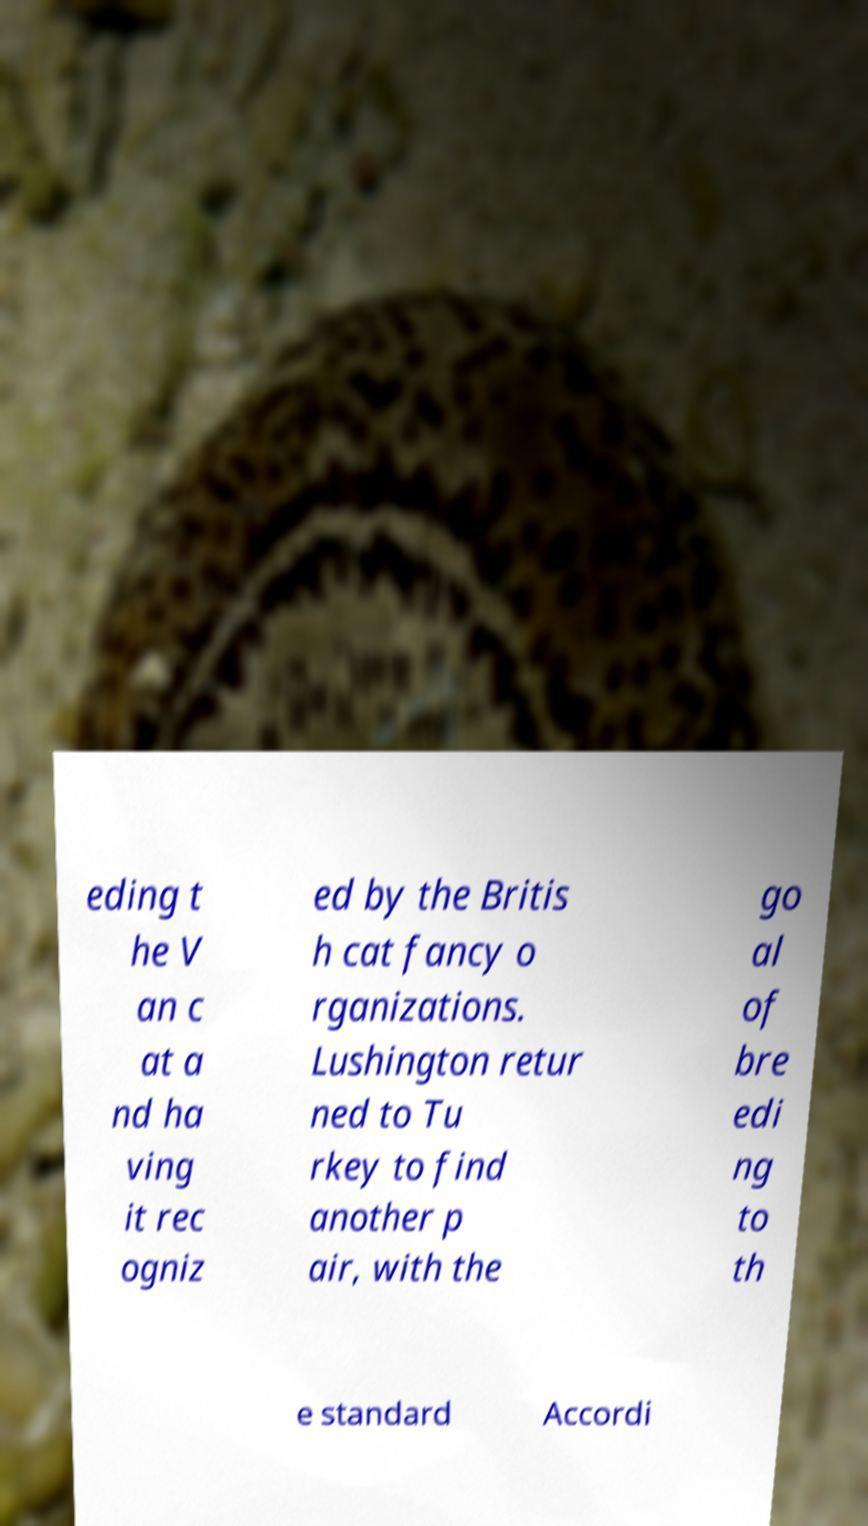What messages or text are displayed in this image? I need them in a readable, typed format. eding t he V an c at a nd ha ving it rec ogniz ed by the Britis h cat fancy o rganizations. Lushington retur ned to Tu rkey to find another p air, with the go al of bre edi ng to th e standard Accordi 